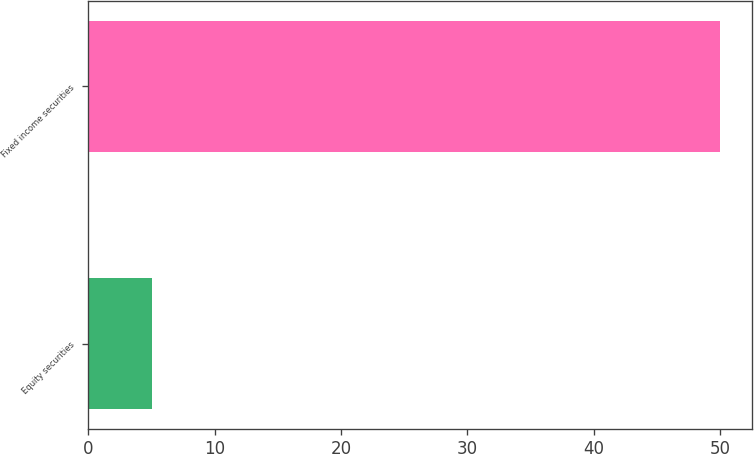Convert chart to OTSL. <chart><loc_0><loc_0><loc_500><loc_500><bar_chart><fcel>Equity securities<fcel>Fixed income securities<nl><fcel>5<fcel>50<nl></chart> 